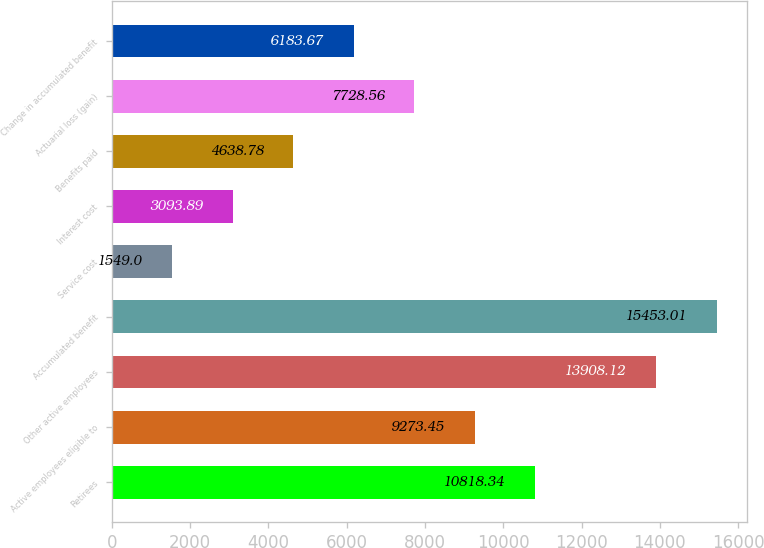Convert chart to OTSL. <chart><loc_0><loc_0><loc_500><loc_500><bar_chart><fcel>Retirees<fcel>Active employees eligible to<fcel>Other active employees<fcel>Accumulated benefit<fcel>Service cost<fcel>Interest cost<fcel>Benefits paid<fcel>Actuarial loss (gain)<fcel>Change in accumulated benefit<nl><fcel>10818.3<fcel>9273.45<fcel>13908.1<fcel>15453<fcel>1549<fcel>3093.89<fcel>4638.78<fcel>7728.56<fcel>6183.67<nl></chart> 